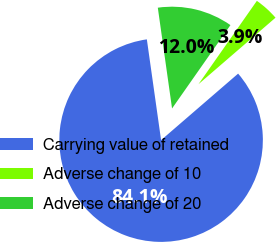Convert chart. <chart><loc_0><loc_0><loc_500><loc_500><pie_chart><fcel>Carrying value of retained<fcel>Adverse change of 10<fcel>Adverse change of 20<nl><fcel>84.1%<fcel>3.94%<fcel>11.96%<nl></chart> 